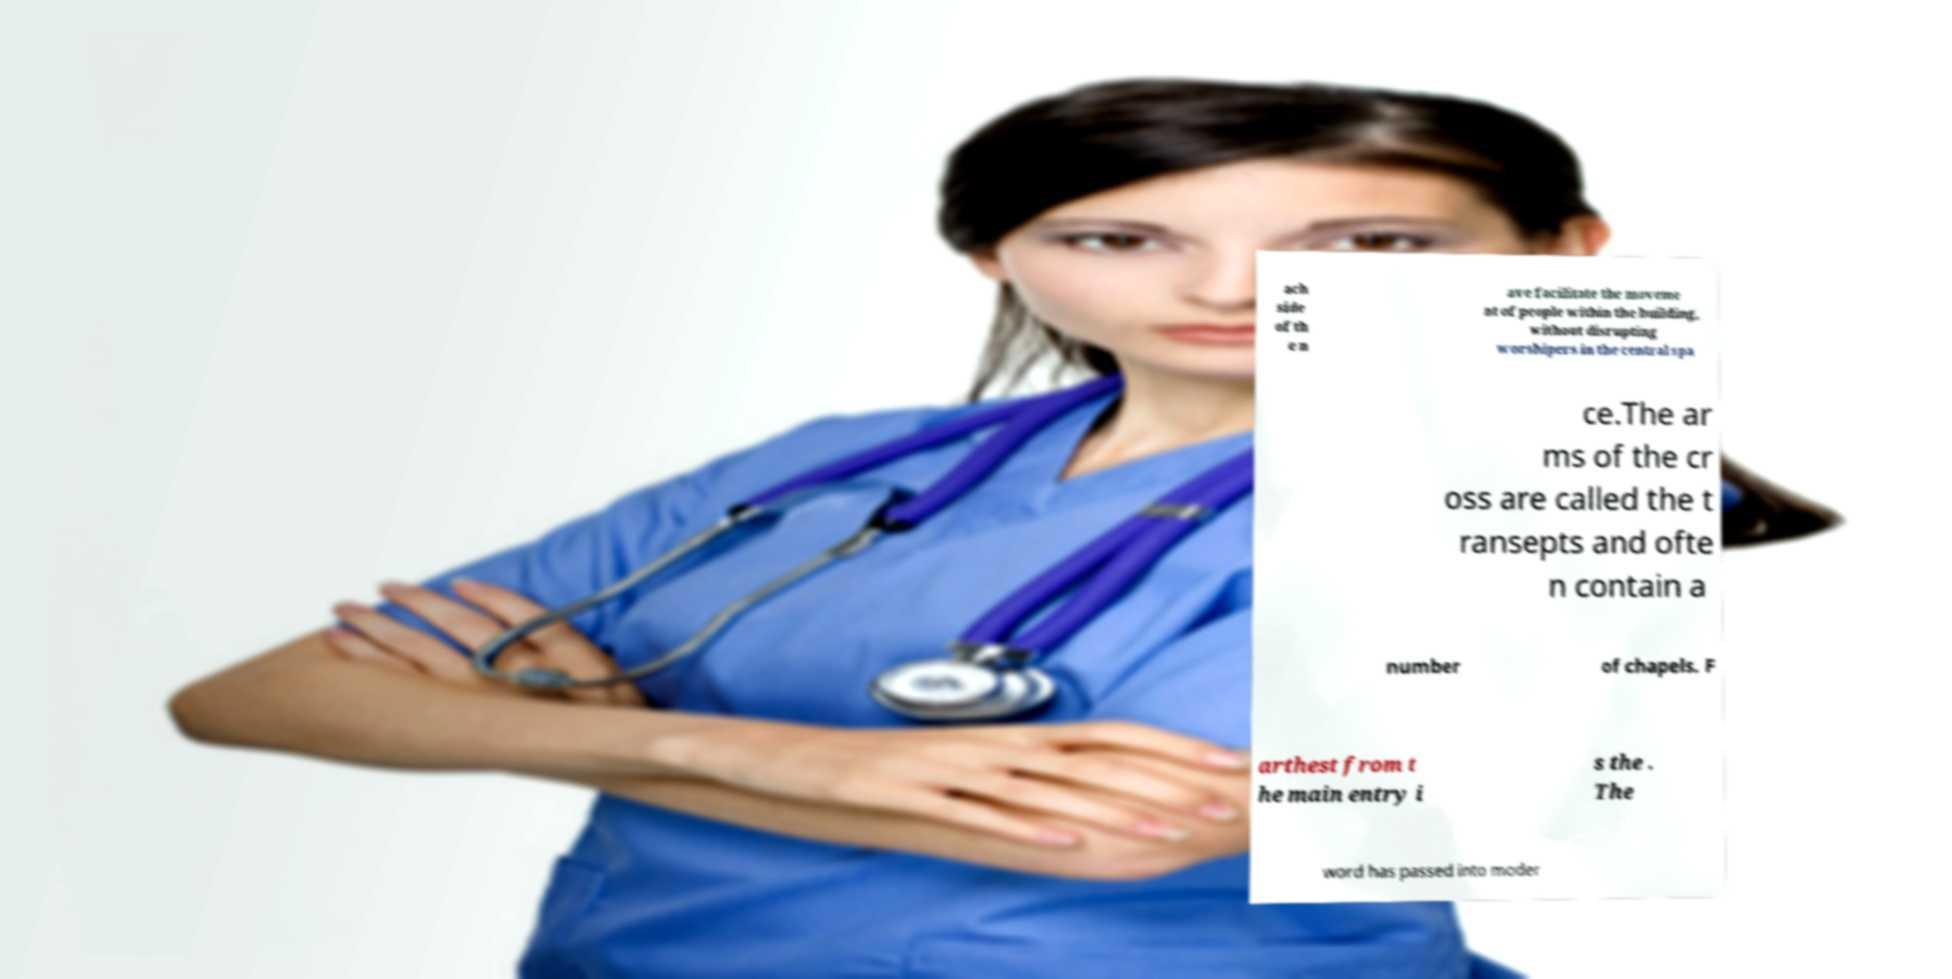Can you accurately transcribe the text from the provided image for me? ach side of th e n ave facilitate the moveme nt of people within the building, without disrupting worshipers in the central spa ce.The ar ms of the cr oss are called the t ransepts and ofte n contain a number of chapels. F arthest from t he main entry i s the . The word has passed into moder 